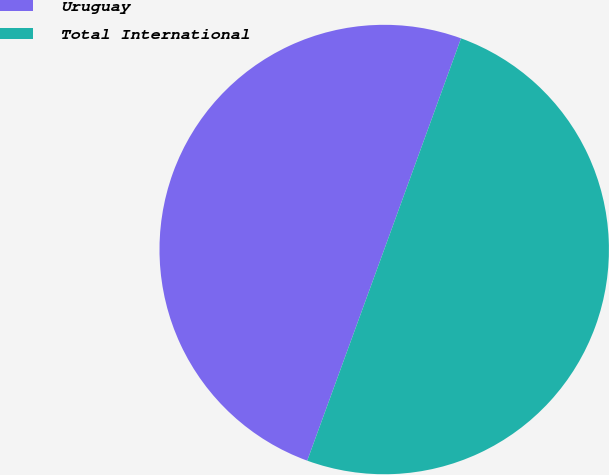<chart> <loc_0><loc_0><loc_500><loc_500><pie_chart><fcel>Uruguay<fcel>Total International<nl><fcel>49.99%<fcel>50.01%<nl></chart> 